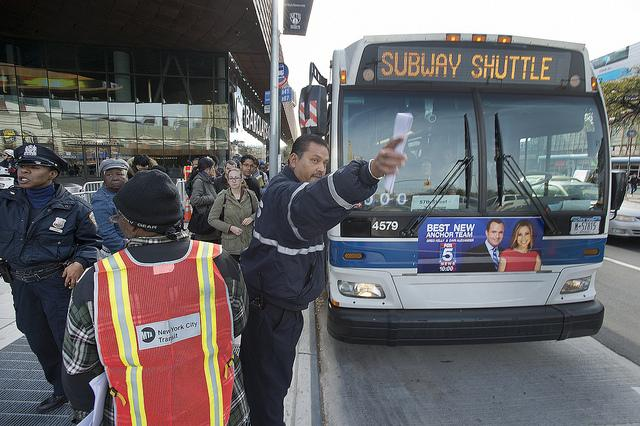What profession is the black man in the blue cap on the left? police officer 